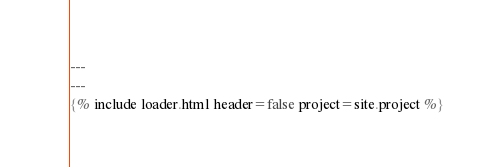Convert code to text. <code><loc_0><loc_0><loc_500><loc_500><_JavaScript_>---
---
{% include loader.html header=false project=site.project %}</code> 